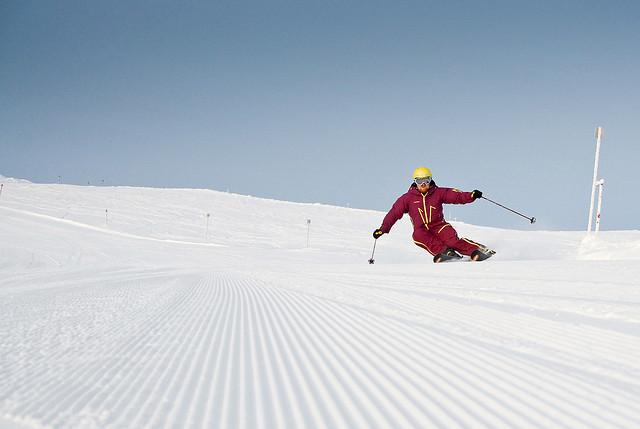Is this person going slowly down the hill?
Be succinct. No. What sport is this?
Be succinct. Skiing. Has the ski slope been groomed recently?
Keep it brief. Yes. What is he wearing?
Be succinct. Snowsuit. Where is the person skiing?
Short answer required. Mountain. 